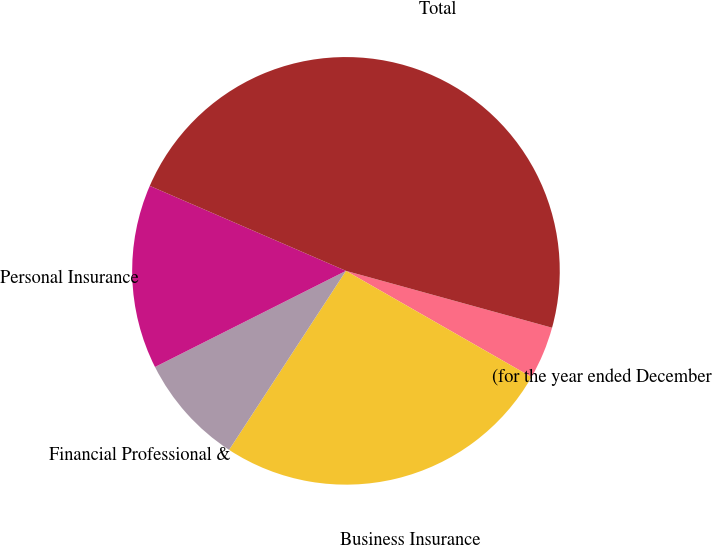<chart> <loc_0><loc_0><loc_500><loc_500><pie_chart><fcel>(for the year ended December<fcel>Business Insurance<fcel>Financial Professional &<fcel>Personal Insurance<fcel>Total<nl><fcel>3.99%<fcel>25.93%<fcel>8.37%<fcel>13.93%<fcel>47.78%<nl></chart> 